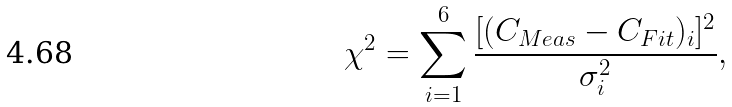Convert formula to latex. <formula><loc_0><loc_0><loc_500><loc_500>\chi ^ { 2 } = \sum _ { i = 1 } ^ { 6 } \frac { [ ( C _ { M e a s } - C _ { F i t } ) _ { i } ] ^ { 2 } } { \sigma _ { i } ^ { 2 } } ,</formula> 